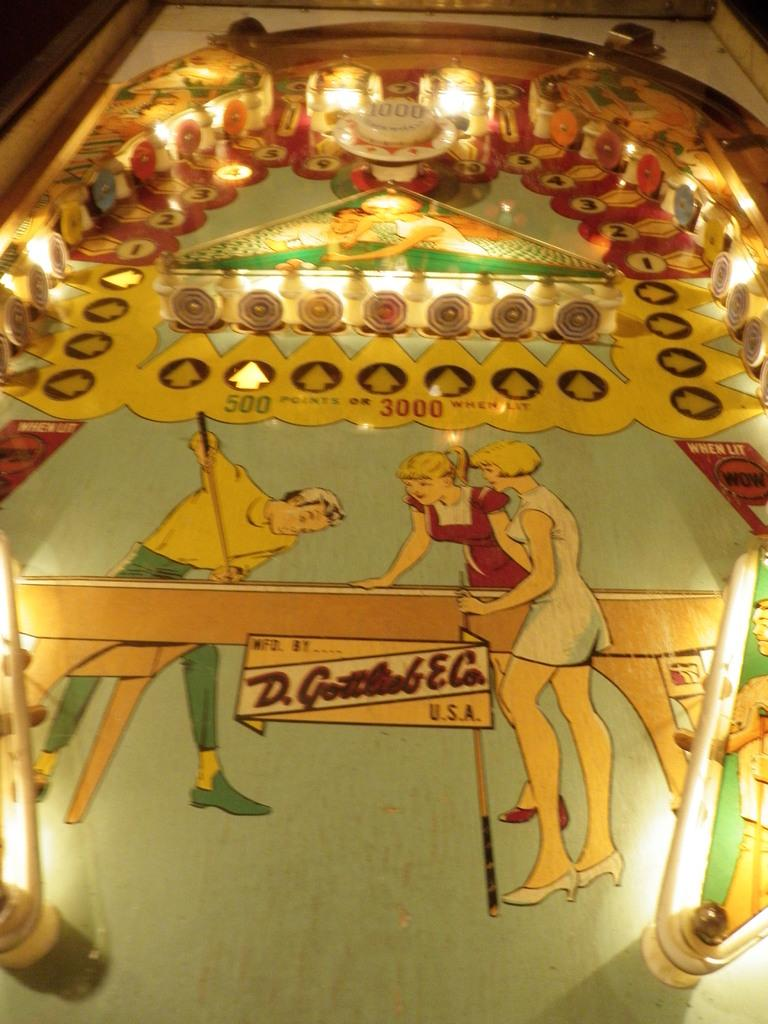What is happening in the image? There are persons standing around a table. What can be seen in the background or above the persons and table? There are lights visible in the image, and there are other objects above the persons and table. Can you describe the lighting in the image? The lights visible in the image provide illumination for the scene. What type of meal is being prepared on the table in the image? There is no meal being prepared on the table in the image; the persons are simply standing around it. 